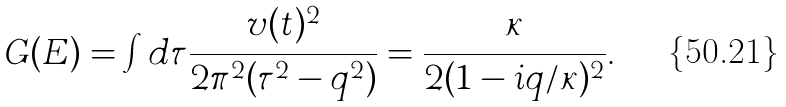<formula> <loc_0><loc_0><loc_500><loc_500>G ( E ) = \int d \tau \frac { v ( t ) ^ { 2 } } { 2 \pi ^ { 2 } ( \tau ^ { 2 } - q ^ { 2 } ) } = \frac { \kappa } { 2 ( 1 - i q / \kappa ) ^ { 2 } } .</formula> 